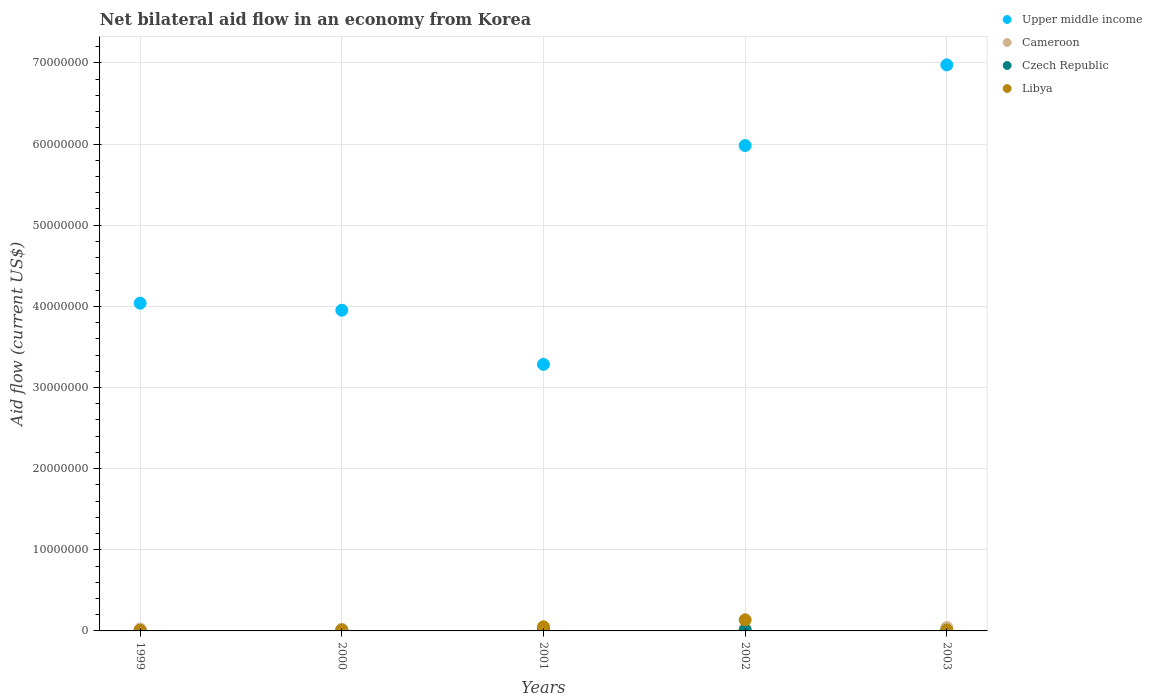How many different coloured dotlines are there?
Give a very brief answer. 4. What is the net bilateral aid flow in Libya in 1999?
Provide a short and direct response. 7.00e+04. Across all years, what is the maximum net bilateral aid flow in Libya?
Your answer should be very brief. 1.37e+06. In which year was the net bilateral aid flow in Upper middle income maximum?
Make the answer very short. 2003. In which year was the net bilateral aid flow in Upper middle income minimum?
Offer a very short reply. 2001. What is the total net bilateral aid flow in Upper middle income in the graph?
Give a very brief answer. 2.42e+08. What is the difference between the net bilateral aid flow in Czech Republic in 1999 and the net bilateral aid flow in Upper middle income in 2000?
Make the answer very short. -3.95e+07. What is the average net bilateral aid flow in Upper middle income per year?
Provide a succinct answer. 4.85e+07. What is the ratio of the net bilateral aid flow in Czech Republic in 2002 to that in 2003?
Keep it short and to the point. 1.22. Is the net bilateral aid flow in Libya in 2002 less than that in 2003?
Provide a succinct answer. No. Is the difference between the net bilateral aid flow in Cameroon in 1999 and 2002 greater than the difference between the net bilateral aid flow in Libya in 1999 and 2002?
Give a very brief answer. Yes. What is the difference between the highest and the second highest net bilateral aid flow in Czech Republic?
Ensure brevity in your answer.  2.00e+04. What is the difference between the highest and the lowest net bilateral aid flow in Libya?
Your answer should be compact. 1.30e+06. In how many years, is the net bilateral aid flow in Upper middle income greater than the average net bilateral aid flow in Upper middle income taken over all years?
Make the answer very short. 2. Is the sum of the net bilateral aid flow in Upper middle income in 2001 and 2003 greater than the maximum net bilateral aid flow in Cameroon across all years?
Provide a short and direct response. Yes. Is the net bilateral aid flow in Libya strictly greater than the net bilateral aid flow in Czech Republic over the years?
Your answer should be compact. Yes. How many dotlines are there?
Offer a very short reply. 4. How many years are there in the graph?
Give a very brief answer. 5. Are the values on the major ticks of Y-axis written in scientific E-notation?
Provide a succinct answer. No. How are the legend labels stacked?
Your response must be concise. Vertical. What is the title of the graph?
Provide a succinct answer. Net bilateral aid flow in an economy from Korea. What is the label or title of the X-axis?
Keep it short and to the point. Years. What is the label or title of the Y-axis?
Provide a succinct answer. Aid flow (current US$). What is the Aid flow (current US$) in Upper middle income in 1999?
Your answer should be compact. 4.04e+07. What is the Aid flow (current US$) of Cameroon in 1999?
Provide a succinct answer. 2.40e+05. What is the Aid flow (current US$) in Czech Republic in 1999?
Offer a terse response. 4.00e+04. What is the Aid flow (current US$) in Libya in 1999?
Ensure brevity in your answer.  7.00e+04. What is the Aid flow (current US$) in Upper middle income in 2000?
Your response must be concise. 3.95e+07. What is the Aid flow (current US$) in Cameroon in 2000?
Ensure brevity in your answer.  2.00e+05. What is the Aid flow (current US$) in Upper middle income in 2001?
Your answer should be very brief. 3.28e+07. What is the Aid flow (current US$) of Libya in 2001?
Provide a short and direct response. 5.10e+05. What is the Aid flow (current US$) in Upper middle income in 2002?
Provide a short and direct response. 5.98e+07. What is the Aid flow (current US$) of Libya in 2002?
Ensure brevity in your answer.  1.37e+06. What is the Aid flow (current US$) in Upper middle income in 2003?
Offer a terse response. 6.98e+07. What is the Aid flow (current US$) in Czech Republic in 2003?
Make the answer very short. 9.00e+04. What is the Aid flow (current US$) of Libya in 2003?
Give a very brief answer. 1.00e+05. Across all years, what is the maximum Aid flow (current US$) of Upper middle income?
Ensure brevity in your answer.  6.98e+07. Across all years, what is the maximum Aid flow (current US$) in Libya?
Provide a succinct answer. 1.37e+06. Across all years, what is the minimum Aid flow (current US$) of Upper middle income?
Offer a terse response. 3.28e+07. Across all years, what is the minimum Aid flow (current US$) in Libya?
Offer a terse response. 7.00e+04. What is the total Aid flow (current US$) in Upper middle income in the graph?
Keep it short and to the point. 2.42e+08. What is the total Aid flow (current US$) of Cameroon in the graph?
Offer a terse response. 1.39e+06. What is the total Aid flow (current US$) in Libya in the graph?
Your answer should be very brief. 2.17e+06. What is the difference between the Aid flow (current US$) in Upper middle income in 1999 and that in 2000?
Provide a succinct answer. 8.70e+05. What is the difference between the Aid flow (current US$) in Libya in 1999 and that in 2000?
Your response must be concise. -5.00e+04. What is the difference between the Aid flow (current US$) of Upper middle income in 1999 and that in 2001?
Keep it short and to the point. 7.54e+06. What is the difference between the Aid flow (current US$) in Cameroon in 1999 and that in 2001?
Provide a succinct answer. 10000. What is the difference between the Aid flow (current US$) in Libya in 1999 and that in 2001?
Provide a succinct answer. -4.40e+05. What is the difference between the Aid flow (current US$) in Upper middle income in 1999 and that in 2002?
Offer a very short reply. -1.94e+07. What is the difference between the Aid flow (current US$) of Libya in 1999 and that in 2002?
Your answer should be compact. -1.30e+06. What is the difference between the Aid flow (current US$) of Upper middle income in 1999 and that in 2003?
Your answer should be compact. -2.94e+07. What is the difference between the Aid flow (current US$) in Upper middle income in 2000 and that in 2001?
Give a very brief answer. 6.67e+06. What is the difference between the Aid flow (current US$) in Libya in 2000 and that in 2001?
Offer a terse response. -3.90e+05. What is the difference between the Aid flow (current US$) in Upper middle income in 2000 and that in 2002?
Ensure brevity in your answer.  -2.03e+07. What is the difference between the Aid flow (current US$) of Cameroon in 2000 and that in 2002?
Keep it short and to the point. -1.00e+05. What is the difference between the Aid flow (current US$) in Libya in 2000 and that in 2002?
Provide a short and direct response. -1.25e+06. What is the difference between the Aid flow (current US$) of Upper middle income in 2000 and that in 2003?
Offer a terse response. -3.02e+07. What is the difference between the Aid flow (current US$) in Czech Republic in 2000 and that in 2003?
Offer a terse response. -7.00e+04. What is the difference between the Aid flow (current US$) of Upper middle income in 2001 and that in 2002?
Make the answer very short. -2.70e+07. What is the difference between the Aid flow (current US$) in Cameroon in 2001 and that in 2002?
Keep it short and to the point. -7.00e+04. What is the difference between the Aid flow (current US$) of Czech Republic in 2001 and that in 2002?
Offer a very short reply. -6.00e+04. What is the difference between the Aid flow (current US$) in Libya in 2001 and that in 2002?
Your response must be concise. -8.60e+05. What is the difference between the Aid flow (current US$) of Upper middle income in 2001 and that in 2003?
Give a very brief answer. -3.69e+07. What is the difference between the Aid flow (current US$) of Libya in 2001 and that in 2003?
Provide a short and direct response. 4.10e+05. What is the difference between the Aid flow (current US$) in Upper middle income in 2002 and that in 2003?
Provide a succinct answer. -9.94e+06. What is the difference between the Aid flow (current US$) in Czech Republic in 2002 and that in 2003?
Keep it short and to the point. 2.00e+04. What is the difference between the Aid flow (current US$) in Libya in 2002 and that in 2003?
Make the answer very short. 1.27e+06. What is the difference between the Aid flow (current US$) of Upper middle income in 1999 and the Aid flow (current US$) of Cameroon in 2000?
Offer a terse response. 4.02e+07. What is the difference between the Aid flow (current US$) in Upper middle income in 1999 and the Aid flow (current US$) in Czech Republic in 2000?
Offer a very short reply. 4.04e+07. What is the difference between the Aid flow (current US$) of Upper middle income in 1999 and the Aid flow (current US$) of Libya in 2000?
Give a very brief answer. 4.03e+07. What is the difference between the Aid flow (current US$) of Cameroon in 1999 and the Aid flow (current US$) of Czech Republic in 2000?
Keep it short and to the point. 2.20e+05. What is the difference between the Aid flow (current US$) of Upper middle income in 1999 and the Aid flow (current US$) of Cameroon in 2001?
Keep it short and to the point. 4.02e+07. What is the difference between the Aid flow (current US$) in Upper middle income in 1999 and the Aid flow (current US$) in Czech Republic in 2001?
Your answer should be compact. 4.03e+07. What is the difference between the Aid flow (current US$) of Upper middle income in 1999 and the Aid flow (current US$) of Libya in 2001?
Provide a short and direct response. 3.99e+07. What is the difference between the Aid flow (current US$) in Cameroon in 1999 and the Aid flow (current US$) in Czech Republic in 2001?
Keep it short and to the point. 1.90e+05. What is the difference between the Aid flow (current US$) in Czech Republic in 1999 and the Aid flow (current US$) in Libya in 2001?
Ensure brevity in your answer.  -4.70e+05. What is the difference between the Aid flow (current US$) of Upper middle income in 1999 and the Aid flow (current US$) of Cameroon in 2002?
Provide a short and direct response. 4.01e+07. What is the difference between the Aid flow (current US$) in Upper middle income in 1999 and the Aid flow (current US$) in Czech Republic in 2002?
Keep it short and to the point. 4.03e+07. What is the difference between the Aid flow (current US$) of Upper middle income in 1999 and the Aid flow (current US$) of Libya in 2002?
Your answer should be very brief. 3.90e+07. What is the difference between the Aid flow (current US$) in Cameroon in 1999 and the Aid flow (current US$) in Czech Republic in 2002?
Provide a short and direct response. 1.30e+05. What is the difference between the Aid flow (current US$) in Cameroon in 1999 and the Aid flow (current US$) in Libya in 2002?
Make the answer very short. -1.13e+06. What is the difference between the Aid flow (current US$) in Czech Republic in 1999 and the Aid flow (current US$) in Libya in 2002?
Provide a succinct answer. -1.33e+06. What is the difference between the Aid flow (current US$) of Upper middle income in 1999 and the Aid flow (current US$) of Cameroon in 2003?
Your response must be concise. 4.00e+07. What is the difference between the Aid flow (current US$) in Upper middle income in 1999 and the Aid flow (current US$) in Czech Republic in 2003?
Offer a very short reply. 4.03e+07. What is the difference between the Aid flow (current US$) of Upper middle income in 1999 and the Aid flow (current US$) of Libya in 2003?
Provide a succinct answer. 4.03e+07. What is the difference between the Aid flow (current US$) of Cameroon in 1999 and the Aid flow (current US$) of Czech Republic in 2003?
Provide a short and direct response. 1.50e+05. What is the difference between the Aid flow (current US$) in Czech Republic in 1999 and the Aid flow (current US$) in Libya in 2003?
Your answer should be compact. -6.00e+04. What is the difference between the Aid flow (current US$) in Upper middle income in 2000 and the Aid flow (current US$) in Cameroon in 2001?
Your answer should be compact. 3.93e+07. What is the difference between the Aid flow (current US$) in Upper middle income in 2000 and the Aid flow (current US$) in Czech Republic in 2001?
Offer a very short reply. 3.95e+07. What is the difference between the Aid flow (current US$) in Upper middle income in 2000 and the Aid flow (current US$) in Libya in 2001?
Your response must be concise. 3.90e+07. What is the difference between the Aid flow (current US$) in Cameroon in 2000 and the Aid flow (current US$) in Czech Republic in 2001?
Your answer should be very brief. 1.50e+05. What is the difference between the Aid flow (current US$) of Cameroon in 2000 and the Aid flow (current US$) of Libya in 2001?
Make the answer very short. -3.10e+05. What is the difference between the Aid flow (current US$) of Czech Republic in 2000 and the Aid flow (current US$) of Libya in 2001?
Your response must be concise. -4.90e+05. What is the difference between the Aid flow (current US$) in Upper middle income in 2000 and the Aid flow (current US$) in Cameroon in 2002?
Ensure brevity in your answer.  3.92e+07. What is the difference between the Aid flow (current US$) of Upper middle income in 2000 and the Aid flow (current US$) of Czech Republic in 2002?
Make the answer very short. 3.94e+07. What is the difference between the Aid flow (current US$) of Upper middle income in 2000 and the Aid flow (current US$) of Libya in 2002?
Keep it short and to the point. 3.82e+07. What is the difference between the Aid flow (current US$) of Cameroon in 2000 and the Aid flow (current US$) of Libya in 2002?
Your answer should be very brief. -1.17e+06. What is the difference between the Aid flow (current US$) of Czech Republic in 2000 and the Aid flow (current US$) of Libya in 2002?
Give a very brief answer. -1.35e+06. What is the difference between the Aid flow (current US$) of Upper middle income in 2000 and the Aid flow (current US$) of Cameroon in 2003?
Give a very brief answer. 3.91e+07. What is the difference between the Aid flow (current US$) in Upper middle income in 2000 and the Aid flow (current US$) in Czech Republic in 2003?
Your answer should be very brief. 3.94e+07. What is the difference between the Aid flow (current US$) in Upper middle income in 2000 and the Aid flow (current US$) in Libya in 2003?
Your answer should be compact. 3.94e+07. What is the difference between the Aid flow (current US$) in Cameroon in 2000 and the Aid flow (current US$) in Czech Republic in 2003?
Provide a short and direct response. 1.10e+05. What is the difference between the Aid flow (current US$) in Upper middle income in 2001 and the Aid flow (current US$) in Cameroon in 2002?
Your answer should be compact. 3.26e+07. What is the difference between the Aid flow (current US$) of Upper middle income in 2001 and the Aid flow (current US$) of Czech Republic in 2002?
Your answer should be compact. 3.27e+07. What is the difference between the Aid flow (current US$) of Upper middle income in 2001 and the Aid flow (current US$) of Libya in 2002?
Keep it short and to the point. 3.15e+07. What is the difference between the Aid flow (current US$) of Cameroon in 2001 and the Aid flow (current US$) of Libya in 2002?
Make the answer very short. -1.14e+06. What is the difference between the Aid flow (current US$) in Czech Republic in 2001 and the Aid flow (current US$) in Libya in 2002?
Your response must be concise. -1.32e+06. What is the difference between the Aid flow (current US$) of Upper middle income in 2001 and the Aid flow (current US$) of Cameroon in 2003?
Your response must be concise. 3.24e+07. What is the difference between the Aid flow (current US$) in Upper middle income in 2001 and the Aid flow (current US$) in Czech Republic in 2003?
Offer a very short reply. 3.28e+07. What is the difference between the Aid flow (current US$) in Upper middle income in 2001 and the Aid flow (current US$) in Libya in 2003?
Your answer should be very brief. 3.28e+07. What is the difference between the Aid flow (current US$) in Czech Republic in 2001 and the Aid flow (current US$) in Libya in 2003?
Offer a terse response. -5.00e+04. What is the difference between the Aid flow (current US$) of Upper middle income in 2002 and the Aid flow (current US$) of Cameroon in 2003?
Keep it short and to the point. 5.94e+07. What is the difference between the Aid flow (current US$) of Upper middle income in 2002 and the Aid flow (current US$) of Czech Republic in 2003?
Ensure brevity in your answer.  5.97e+07. What is the difference between the Aid flow (current US$) of Upper middle income in 2002 and the Aid flow (current US$) of Libya in 2003?
Provide a short and direct response. 5.97e+07. What is the average Aid flow (current US$) of Upper middle income per year?
Offer a very short reply. 4.85e+07. What is the average Aid flow (current US$) of Cameroon per year?
Your answer should be compact. 2.78e+05. What is the average Aid flow (current US$) of Czech Republic per year?
Provide a short and direct response. 6.20e+04. What is the average Aid flow (current US$) in Libya per year?
Your answer should be very brief. 4.34e+05. In the year 1999, what is the difference between the Aid flow (current US$) in Upper middle income and Aid flow (current US$) in Cameroon?
Keep it short and to the point. 4.02e+07. In the year 1999, what is the difference between the Aid flow (current US$) of Upper middle income and Aid flow (current US$) of Czech Republic?
Give a very brief answer. 4.04e+07. In the year 1999, what is the difference between the Aid flow (current US$) of Upper middle income and Aid flow (current US$) of Libya?
Ensure brevity in your answer.  4.03e+07. In the year 1999, what is the difference between the Aid flow (current US$) in Cameroon and Aid flow (current US$) in Libya?
Give a very brief answer. 1.70e+05. In the year 1999, what is the difference between the Aid flow (current US$) of Czech Republic and Aid flow (current US$) of Libya?
Your response must be concise. -3.00e+04. In the year 2000, what is the difference between the Aid flow (current US$) in Upper middle income and Aid flow (current US$) in Cameroon?
Your answer should be very brief. 3.93e+07. In the year 2000, what is the difference between the Aid flow (current US$) of Upper middle income and Aid flow (current US$) of Czech Republic?
Offer a very short reply. 3.95e+07. In the year 2000, what is the difference between the Aid flow (current US$) in Upper middle income and Aid flow (current US$) in Libya?
Offer a terse response. 3.94e+07. In the year 2000, what is the difference between the Aid flow (current US$) of Cameroon and Aid flow (current US$) of Czech Republic?
Your answer should be compact. 1.80e+05. In the year 2000, what is the difference between the Aid flow (current US$) in Czech Republic and Aid flow (current US$) in Libya?
Offer a terse response. -1.00e+05. In the year 2001, what is the difference between the Aid flow (current US$) in Upper middle income and Aid flow (current US$) in Cameroon?
Offer a terse response. 3.26e+07. In the year 2001, what is the difference between the Aid flow (current US$) in Upper middle income and Aid flow (current US$) in Czech Republic?
Your answer should be compact. 3.28e+07. In the year 2001, what is the difference between the Aid flow (current US$) of Upper middle income and Aid flow (current US$) of Libya?
Provide a succinct answer. 3.23e+07. In the year 2001, what is the difference between the Aid flow (current US$) of Cameroon and Aid flow (current US$) of Libya?
Provide a succinct answer. -2.80e+05. In the year 2001, what is the difference between the Aid flow (current US$) of Czech Republic and Aid flow (current US$) of Libya?
Provide a short and direct response. -4.60e+05. In the year 2002, what is the difference between the Aid flow (current US$) of Upper middle income and Aid flow (current US$) of Cameroon?
Provide a short and direct response. 5.95e+07. In the year 2002, what is the difference between the Aid flow (current US$) of Upper middle income and Aid flow (current US$) of Czech Republic?
Your answer should be very brief. 5.97e+07. In the year 2002, what is the difference between the Aid flow (current US$) of Upper middle income and Aid flow (current US$) of Libya?
Give a very brief answer. 5.84e+07. In the year 2002, what is the difference between the Aid flow (current US$) in Cameroon and Aid flow (current US$) in Czech Republic?
Your response must be concise. 1.90e+05. In the year 2002, what is the difference between the Aid flow (current US$) of Cameroon and Aid flow (current US$) of Libya?
Your answer should be very brief. -1.07e+06. In the year 2002, what is the difference between the Aid flow (current US$) of Czech Republic and Aid flow (current US$) of Libya?
Ensure brevity in your answer.  -1.26e+06. In the year 2003, what is the difference between the Aid flow (current US$) in Upper middle income and Aid flow (current US$) in Cameroon?
Provide a short and direct response. 6.93e+07. In the year 2003, what is the difference between the Aid flow (current US$) of Upper middle income and Aid flow (current US$) of Czech Republic?
Keep it short and to the point. 6.97e+07. In the year 2003, what is the difference between the Aid flow (current US$) in Upper middle income and Aid flow (current US$) in Libya?
Your response must be concise. 6.97e+07. In the year 2003, what is the difference between the Aid flow (current US$) of Cameroon and Aid flow (current US$) of Czech Republic?
Offer a terse response. 3.30e+05. What is the ratio of the Aid flow (current US$) in Upper middle income in 1999 to that in 2000?
Your answer should be very brief. 1.02. What is the ratio of the Aid flow (current US$) in Czech Republic in 1999 to that in 2000?
Your response must be concise. 2. What is the ratio of the Aid flow (current US$) of Libya in 1999 to that in 2000?
Your answer should be very brief. 0.58. What is the ratio of the Aid flow (current US$) of Upper middle income in 1999 to that in 2001?
Your answer should be very brief. 1.23. What is the ratio of the Aid flow (current US$) of Cameroon in 1999 to that in 2001?
Your answer should be very brief. 1.04. What is the ratio of the Aid flow (current US$) of Libya in 1999 to that in 2001?
Offer a terse response. 0.14. What is the ratio of the Aid flow (current US$) in Upper middle income in 1999 to that in 2002?
Your response must be concise. 0.68. What is the ratio of the Aid flow (current US$) of Czech Republic in 1999 to that in 2002?
Provide a short and direct response. 0.36. What is the ratio of the Aid flow (current US$) of Libya in 1999 to that in 2002?
Ensure brevity in your answer.  0.05. What is the ratio of the Aid flow (current US$) of Upper middle income in 1999 to that in 2003?
Make the answer very short. 0.58. What is the ratio of the Aid flow (current US$) in Cameroon in 1999 to that in 2003?
Your answer should be compact. 0.57. What is the ratio of the Aid flow (current US$) of Czech Republic in 1999 to that in 2003?
Give a very brief answer. 0.44. What is the ratio of the Aid flow (current US$) in Upper middle income in 2000 to that in 2001?
Provide a short and direct response. 1.2. What is the ratio of the Aid flow (current US$) of Cameroon in 2000 to that in 2001?
Your response must be concise. 0.87. What is the ratio of the Aid flow (current US$) in Libya in 2000 to that in 2001?
Provide a succinct answer. 0.24. What is the ratio of the Aid flow (current US$) in Upper middle income in 2000 to that in 2002?
Offer a very short reply. 0.66. What is the ratio of the Aid flow (current US$) of Czech Republic in 2000 to that in 2002?
Provide a short and direct response. 0.18. What is the ratio of the Aid flow (current US$) of Libya in 2000 to that in 2002?
Your answer should be very brief. 0.09. What is the ratio of the Aid flow (current US$) of Upper middle income in 2000 to that in 2003?
Your answer should be very brief. 0.57. What is the ratio of the Aid flow (current US$) of Cameroon in 2000 to that in 2003?
Give a very brief answer. 0.48. What is the ratio of the Aid flow (current US$) in Czech Republic in 2000 to that in 2003?
Give a very brief answer. 0.22. What is the ratio of the Aid flow (current US$) of Upper middle income in 2001 to that in 2002?
Your response must be concise. 0.55. What is the ratio of the Aid flow (current US$) of Cameroon in 2001 to that in 2002?
Ensure brevity in your answer.  0.77. What is the ratio of the Aid flow (current US$) of Czech Republic in 2001 to that in 2002?
Make the answer very short. 0.45. What is the ratio of the Aid flow (current US$) in Libya in 2001 to that in 2002?
Ensure brevity in your answer.  0.37. What is the ratio of the Aid flow (current US$) of Upper middle income in 2001 to that in 2003?
Offer a terse response. 0.47. What is the ratio of the Aid flow (current US$) of Cameroon in 2001 to that in 2003?
Give a very brief answer. 0.55. What is the ratio of the Aid flow (current US$) of Czech Republic in 2001 to that in 2003?
Offer a terse response. 0.56. What is the ratio of the Aid flow (current US$) of Upper middle income in 2002 to that in 2003?
Offer a terse response. 0.86. What is the ratio of the Aid flow (current US$) of Czech Republic in 2002 to that in 2003?
Make the answer very short. 1.22. What is the difference between the highest and the second highest Aid flow (current US$) of Upper middle income?
Your answer should be compact. 9.94e+06. What is the difference between the highest and the second highest Aid flow (current US$) in Cameroon?
Make the answer very short. 1.20e+05. What is the difference between the highest and the second highest Aid flow (current US$) in Czech Republic?
Provide a short and direct response. 2.00e+04. What is the difference between the highest and the second highest Aid flow (current US$) in Libya?
Offer a terse response. 8.60e+05. What is the difference between the highest and the lowest Aid flow (current US$) of Upper middle income?
Ensure brevity in your answer.  3.69e+07. What is the difference between the highest and the lowest Aid flow (current US$) in Cameroon?
Offer a very short reply. 2.20e+05. What is the difference between the highest and the lowest Aid flow (current US$) in Libya?
Your answer should be very brief. 1.30e+06. 